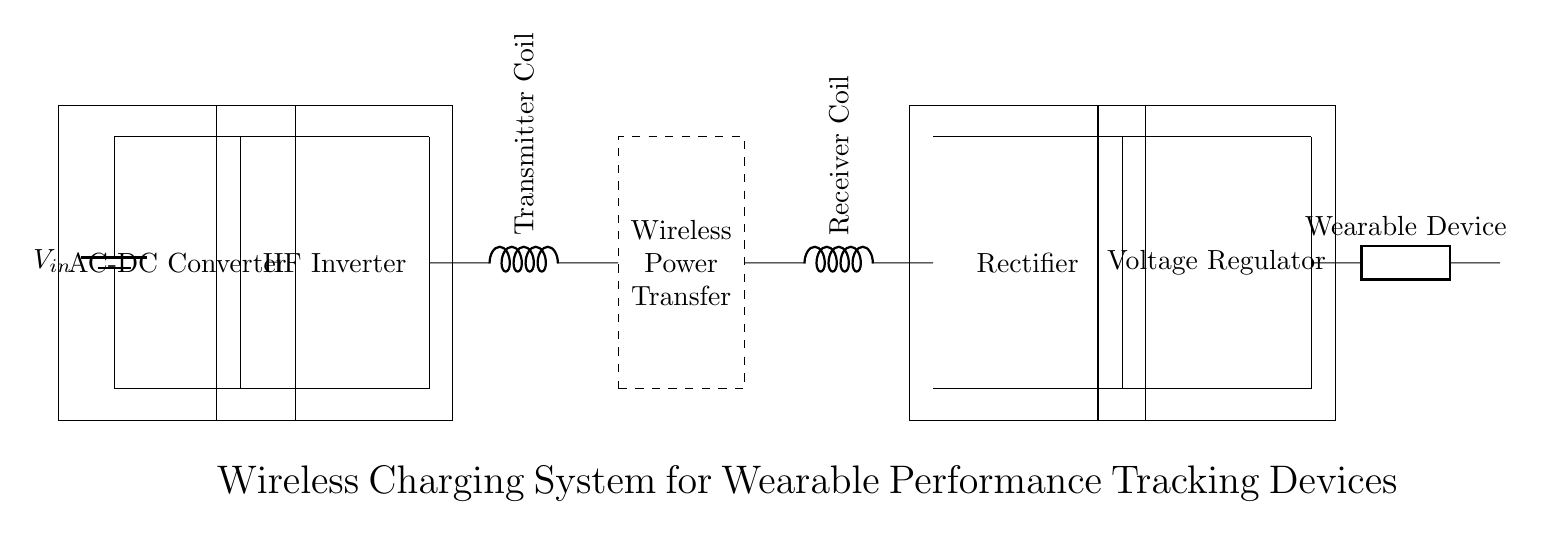what is the first component in the circuit? The first component in the circuit is a battery, which serves as the power source providing voltage input.
Answer: battery what connects the AC-DC converter to the high frequency inverter? The AC-DC converter is connected to the high frequency inverter via direct wire connections that carry the converted direct current.
Answer: wires what is the purpose of the rectifier? The rectifier converts alternating current back into direct current after it has been transmitted, ensuring that the wearable device receives the appropriate voltage type.
Answer: conversion how many coils are present in this circuit? There are two coils in the circuit: a transmitter coil and a receiver coil, which are critical for the wireless power transfer.
Answer: two explain the flow of energy from the battery to the wearable device. Energy from the battery flows into the AC-DC converter, which changes the AC voltage into DC. The DC energy then goes to the high frequency inverter, which creates a high frequency signal used by the transmitter coil. This signal is wirelessly transferred to the receiver coil, where it is converted back to DC by the rectifier and regulated before powering the wearable device.
Answer: battery to wearable device what role does the voltage regulator play in this circuit? The voltage regulator ensures that the voltage supplied to the wearable device is stable and suitable for operation, regardless of fluctuations in input from the rectifier.
Answer: stabilization 